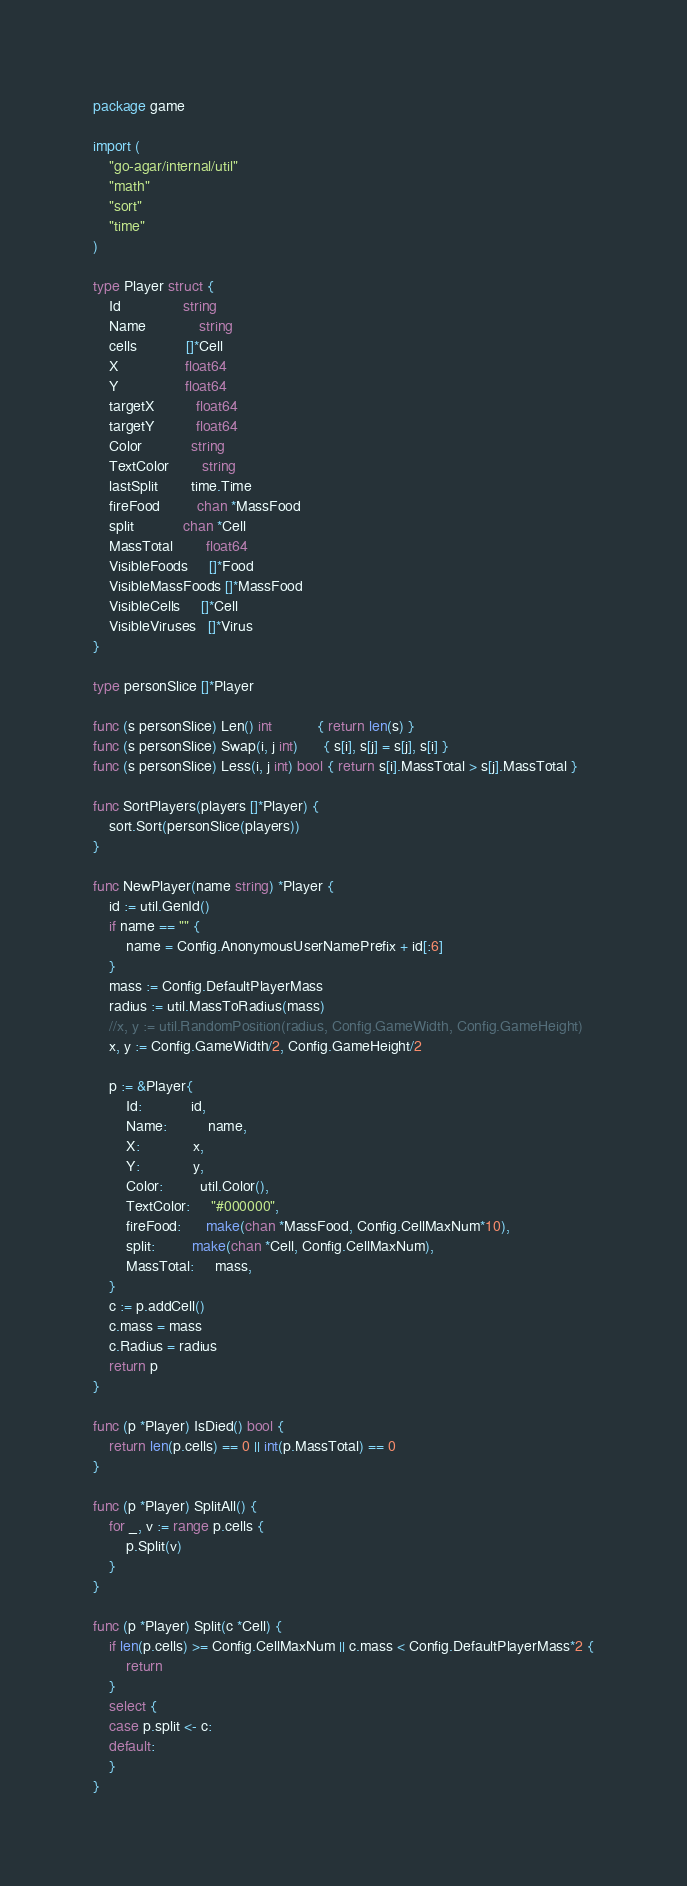<code> <loc_0><loc_0><loc_500><loc_500><_Go_>package game

import (
	"go-agar/internal/util"
	"math"
	"sort"
	"time"
)

type Player struct {
	Id               string
	Name             string
	cells            []*Cell
	X                float64
	Y                float64
	targetX          float64
	targetY          float64
	Color            string
	TextColor        string
	lastSplit        time.Time
	fireFood         chan *MassFood
	split            chan *Cell
	MassTotal        float64
	VisibleFoods     []*Food
	VisibleMassFoods []*MassFood
	VisibleCells     []*Cell
	VisibleViruses   []*Virus
}

type personSlice []*Player

func (s personSlice) Len() int           { return len(s) }
func (s personSlice) Swap(i, j int)      { s[i], s[j] = s[j], s[i] }
func (s personSlice) Less(i, j int) bool { return s[i].MassTotal > s[j].MassTotal }

func SortPlayers(players []*Player) {
	sort.Sort(personSlice(players))
}

func NewPlayer(name string) *Player {
	id := util.GenId()
	if name == "" {
		name = Config.AnonymousUserNamePrefix + id[:6]
	}
	mass := Config.DefaultPlayerMass
	radius := util.MassToRadius(mass)
	//x, y := util.RandomPosition(radius, Config.GameWidth, Config.GameHeight)
	x, y := Config.GameWidth/2, Config.GameHeight/2

	p := &Player{
		Id:            id,
		Name:          name,
		X:             x,
		Y:             y,
		Color:         util.Color(),
		TextColor:     "#000000",
		fireFood:      make(chan *MassFood, Config.CellMaxNum*10),
		split:         make(chan *Cell, Config.CellMaxNum),
		MassTotal:     mass,
	}
	c := p.addCell()
	c.mass = mass
	c.Radius = radius
	return p
}

func (p *Player) IsDied() bool {
	return len(p.cells) == 0 || int(p.MassTotal) == 0
}

func (p *Player) SplitAll() {
	for _, v := range p.cells {
		p.Split(v)
	}
}

func (p *Player) Split(c *Cell) {
	if len(p.cells) >= Config.CellMaxNum || c.mass < Config.DefaultPlayerMass*2 {
		return
	}
	select {
	case p.split <- c:
	default:
	}
}
</code> 